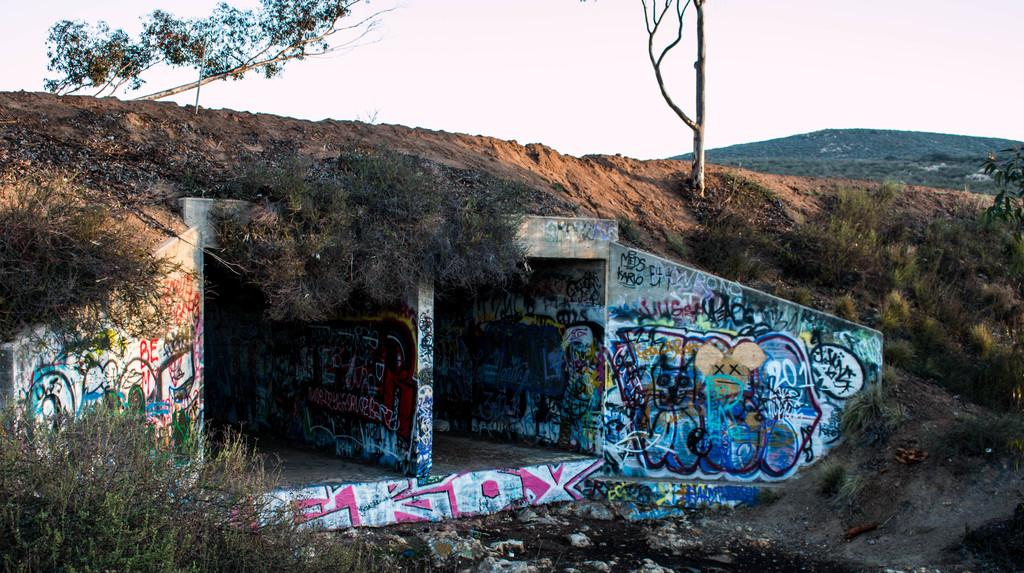<image>
Describe the image concisely. A tunnel under the earth has been marked by graffiti including a tag marked "EROX." 